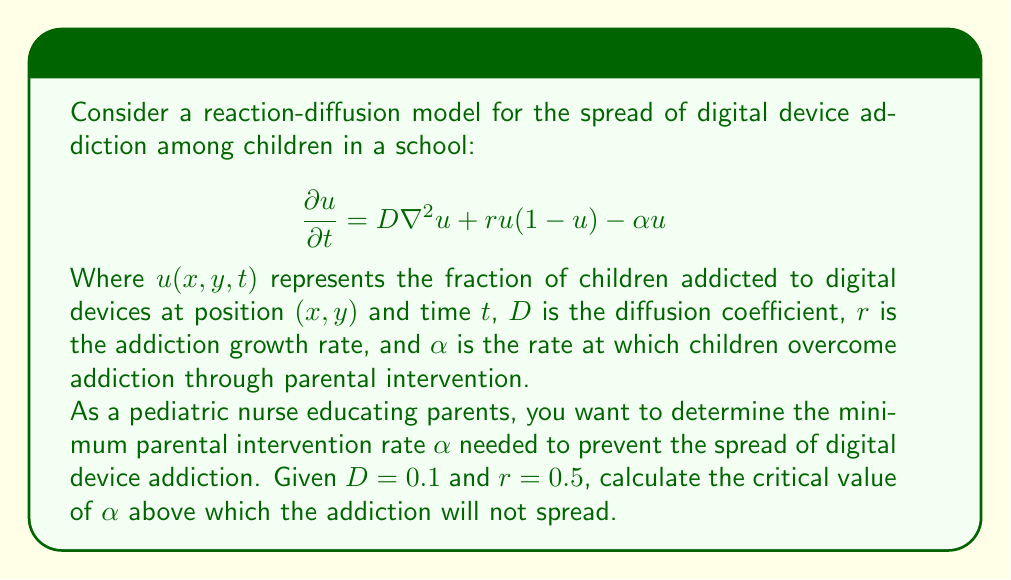Could you help me with this problem? To solve this problem, we need to understand the conditions for the spread of addiction in a reaction-diffusion equation. The addiction will not spread if the homogeneous steady state $u = 0$ is stable.

1) First, we linearize the equation around $u = 0$:
   $$\frac{\partial u}{\partial t} \approx D\nabla^2u + (r - \alpha)u$$

2) We then consider solutions of the form $u = e^{\lambda t}e^{i\mathbf{k}\cdot\mathbf{x}}$, where $\mathbf{k} = (k_x, k_y)$ is the wave vector.

3) Substituting this into our linearized equation:
   $$\lambda e^{\lambda t}e^{i\mathbf{k}\cdot\mathbf{x}} = -D|\mathbf{k}|^2 e^{\lambda t}e^{i\mathbf{k}\cdot\mathbf{x}} + (r - \alpha)e^{\lambda t}e^{i\mathbf{k}\cdot\mathbf{x}}$$

4) Simplifying:
   $$\lambda = -D|\mathbf{k}|^2 + (r - \alpha)$$

5) For stability, we need $\lambda < 0$ for all $\mathbf{k}$. The most unstable mode is $\mathbf{k} = 0$, so we require:
   $$r - \alpha < 0$$

6) Therefore, the critical value of $\alpha$ is:
   $$\alpha_{\text{critical}} = r = 0.5$$

7) For any $\alpha > \alpha_{\text{critical}}$, the addiction will not spread.
Answer: The critical value of $\alpha$ is 0.5. Any parental intervention rate higher than this will prevent the spread of digital device addiction among children. 